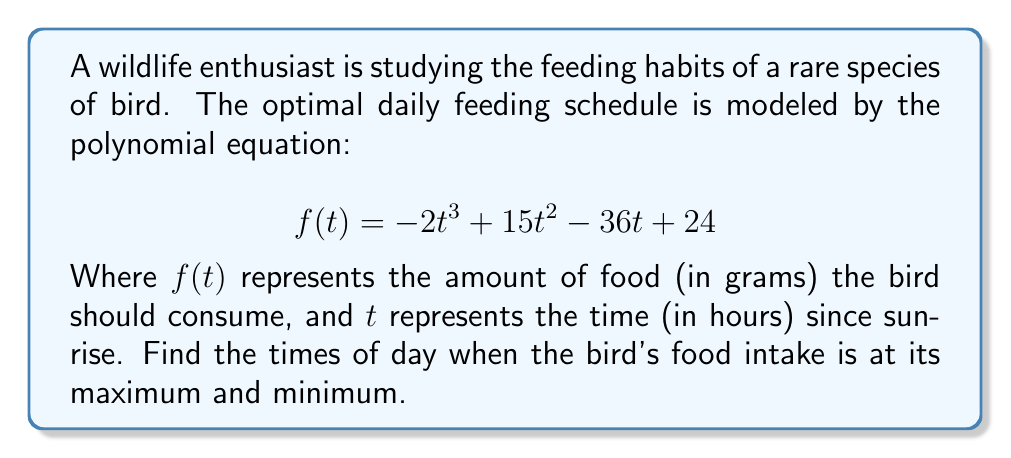Can you solve this math problem? To find the maximum and minimum points of the feeding schedule, we need to find the roots of the derivative of $f(t)$.

Step 1: Calculate the derivative of $f(t)$
$$f'(t) = -6t^2 + 30t - 36$$

Step 2: Set $f'(t) = 0$ and solve for $t$
$$-6t^2 + 30t - 36 = 0$$

Step 3: Factor the quadratic equation
$$-6(t^2 - 5t + 6) = 0$$
$$-6(t - 2)(t - 3) = 0$$

Step 4: Solve for $t$
$t = 2$ or $t = 3$

Step 5: Determine which point is the maximum and which is the minimum
Calculate $f''(t) = -12t + 30$
At $t = 2$: $f''(2) = 6 > 0$, so $t = 2$ is a local minimum
At $t = 3$: $f''(3) = -6 < 0$, so $t = 3$ is a local maximum

Therefore, the bird's food intake is at its minimum 2 hours after sunrise and at its maximum 3 hours after sunrise.
Answer: Minimum: 2 hours after sunrise; Maximum: 3 hours after sunrise 